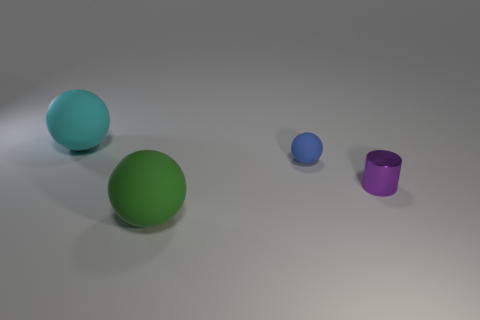There is a cylinder that is behind the big matte thing that is in front of the cyan rubber sphere; what is it made of?
Your response must be concise. Metal. There is a thing on the left side of the green matte thing; what size is it?
Make the answer very short. Large. There is a small shiny cylinder; is it the same color as the big matte object in front of the purple cylinder?
Provide a succinct answer. No. Does the large green sphere have the same material as the big cyan ball that is on the left side of the blue thing?
Your response must be concise. Yes. What number of large things are either cyan shiny spheres or cyan matte objects?
Provide a short and direct response. 1. Is the number of objects less than the number of red rubber objects?
Your response must be concise. No. There is a purple metal cylinder in front of the cyan matte thing; is it the same size as the ball behind the blue ball?
Offer a terse response. No. What number of blue things are either metal objects or small matte spheres?
Your answer should be very brief. 1. Are there more matte spheres than tiny blue rubber cubes?
Give a very brief answer. Yes. What number of things are either blue rubber cylinders or objects on the right side of the large cyan rubber sphere?
Make the answer very short. 3. 